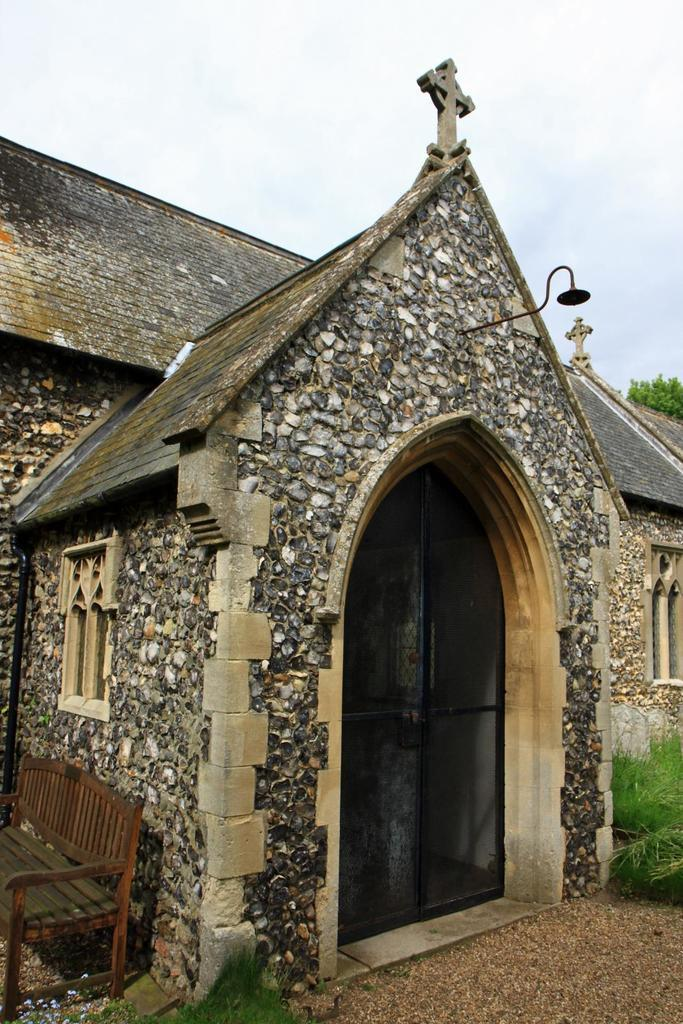What type of structure is visible in the image? There is a building in the image. What features can be seen on the building? The building has doors, windows, a cross, and a lamp. Are there any additional elements near the building? Yes, there are plants and a bench on the sides of the building. What can be seen in the background of the image? The sky is visible in the background of the image. How many girls are sitting on the bench in the image? There are no girls present in the image; the bench is empty. What type of birds can be seen flying near the building in the image? There are no birds visible in the image; only the building, its features, and the surrounding elements are present. 